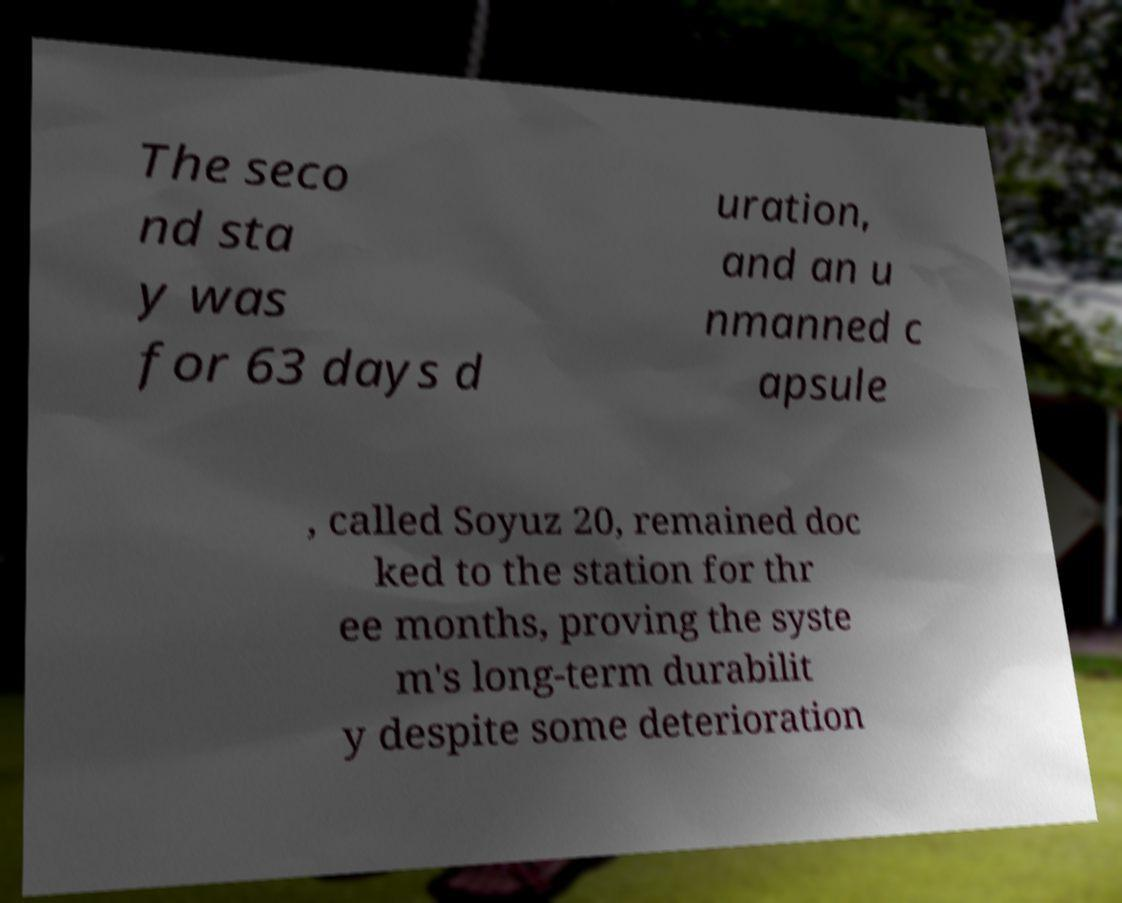What messages or text are displayed in this image? I need them in a readable, typed format. The seco nd sta y was for 63 days d uration, and an u nmanned c apsule , called Soyuz 20, remained doc ked to the station for thr ee months, proving the syste m's long-term durabilit y despite some deterioration 